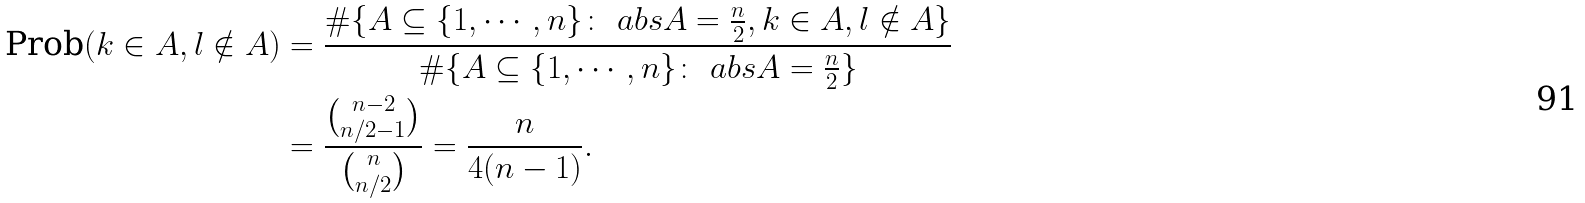Convert formula to latex. <formula><loc_0><loc_0><loc_500><loc_500>\text {Prob} ( k \in A , l \notin A ) & = \frac { \# \{ A \subseteq \{ 1 , \cdots , n \} \colon \ a b s { A } = \frac { n } { 2 } , k \in A , l \notin A \} } { \# \{ A \subseteq \{ 1 , \cdots , n \} \colon \ a b s { A } = \frac { n } { 2 } \} } \\ & = \frac { \binom { n - 2 } { n / 2 - 1 } } { \binom { n } { n / 2 } } = \frac { n } { 4 ( n - 1 ) } .</formula> 